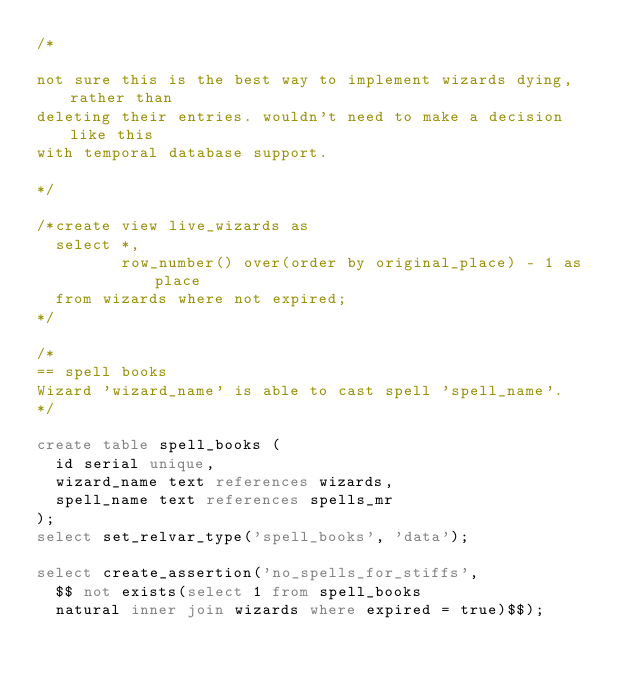Convert code to text. <code><loc_0><loc_0><loc_500><loc_500><_SQL_>/*

not sure this is the best way to implement wizards dying, rather than
deleting their entries. wouldn't need to make a decision like this
with temporal database support.

*/

/*create view live_wizards as
  select *,
         row_number() over(order by original_place) - 1 as place
  from wizards where not expired;
*/

/*
== spell books
Wizard 'wizard_name' is able to cast spell 'spell_name'.
*/

create table spell_books (
  id serial unique,
  wizard_name text references wizards,
  spell_name text references spells_mr
);
select set_relvar_type('spell_books', 'data');

select create_assertion('no_spells_for_stiffs',
  $$ not exists(select 1 from spell_books
  natural inner join wizards where expired = true)$$);
</code> 